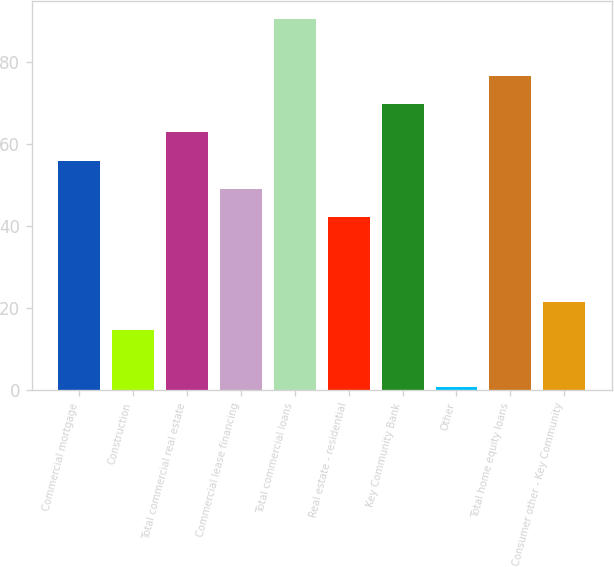<chart> <loc_0><loc_0><loc_500><loc_500><bar_chart><fcel>Commercial mortgage<fcel>Construction<fcel>Total commercial real estate<fcel>Commercial lease financing<fcel>Total commercial loans<fcel>Real estate - residential<fcel>Key Community Bank<fcel>Other<fcel>Total home equity loans<fcel>Consumer other - Key Community<nl><fcel>56<fcel>14.6<fcel>62.9<fcel>49.1<fcel>90.5<fcel>42.2<fcel>69.8<fcel>0.8<fcel>76.7<fcel>21.5<nl></chart> 